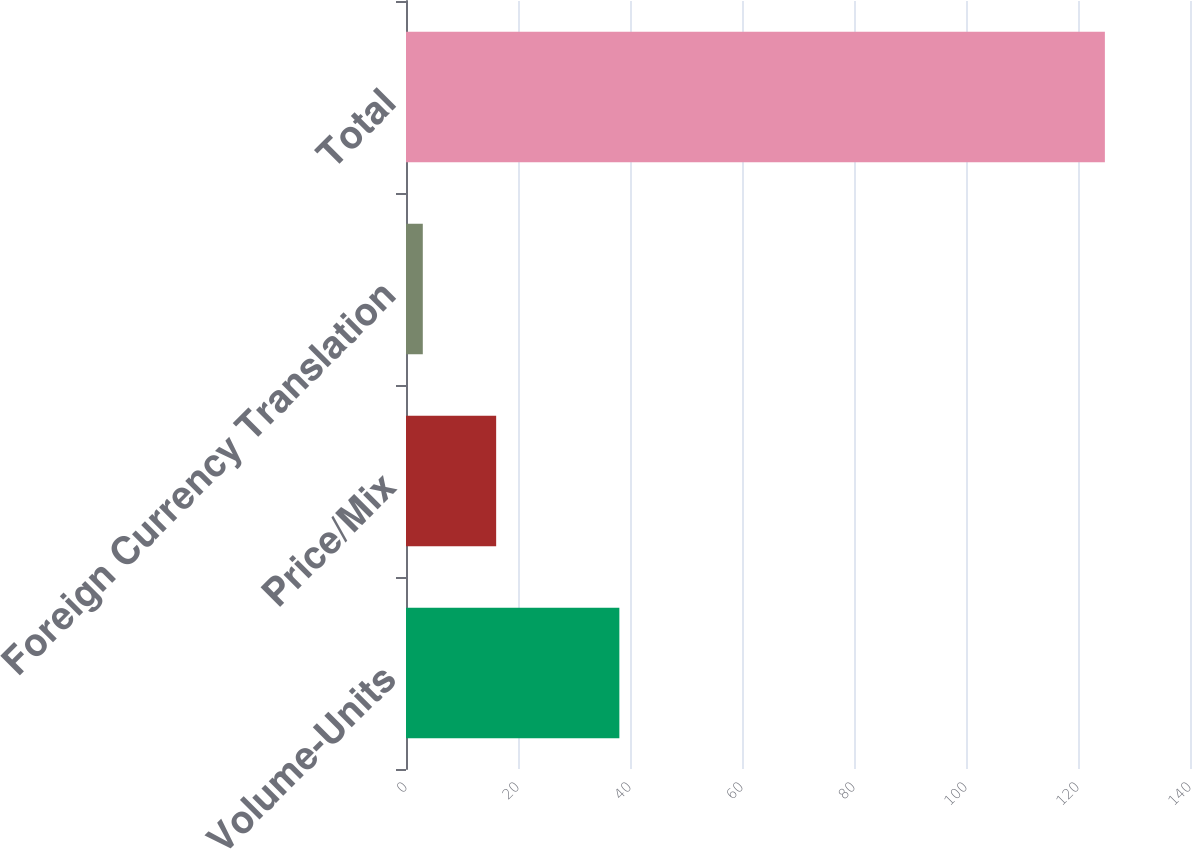Convert chart. <chart><loc_0><loc_0><loc_500><loc_500><bar_chart><fcel>Volume-Units<fcel>Price/Mix<fcel>Foreign Currency Translation<fcel>Total<nl><fcel>38.1<fcel>16.1<fcel>3<fcel>124.8<nl></chart> 